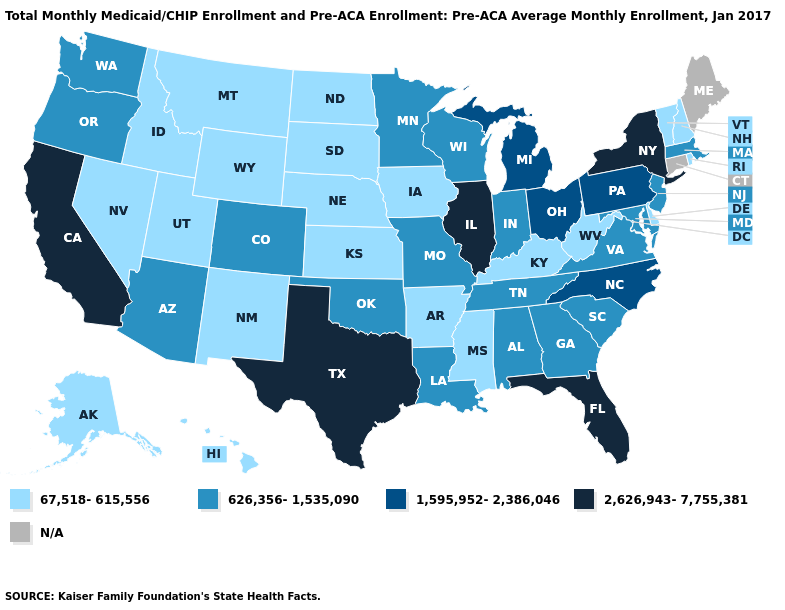What is the highest value in states that border New Jersey?
Give a very brief answer. 2,626,943-7,755,381. How many symbols are there in the legend?
Write a very short answer. 5. What is the value of South Carolina?
Give a very brief answer. 626,356-1,535,090. Does Louisiana have the lowest value in the South?
Concise answer only. No. What is the value of Pennsylvania?
Short answer required. 1,595,952-2,386,046. Does Idaho have the lowest value in the USA?
Be succinct. Yes. What is the lowest value in the West?
Give a very brief answer. 67,518-615,556. Name the states that have a value in the range 2,626,943-7,755,381?
Short answer required. California, Florida, Illinois, New York, Texas. Which states hav the highest value in the West?
Keep it brief. California. Among the states that border Minnesota , does Wisconsin have the highest value?
Short answer required. Yes. Which states have the lowest value in the South?
Keep it brief. Arkansas, Delaware, Kentucky, Mississippi, West Virginia. What is the highest value in the USA?
Concise answer only. 2,626,943-7,755,381. What is the value of California?
Quick response, please. 2,626,943-7,755,381. Name the states that have a value in the range 67,518-615,556?
Write a very short answer. Alaska, Arkansas, Delaware, Hawaii, Idaho, Iowa, Kansas, Kentucky, Mississippi, Montana, Nebraska, Nevada, New Hampshire, New Mexico, North Dakota, Rhode Island, South Dakota, Utah, Vermont, West Virginia, Wyoming. What is the value of Illinois?
Concise answer only. 2,626,943-7,755,381. 